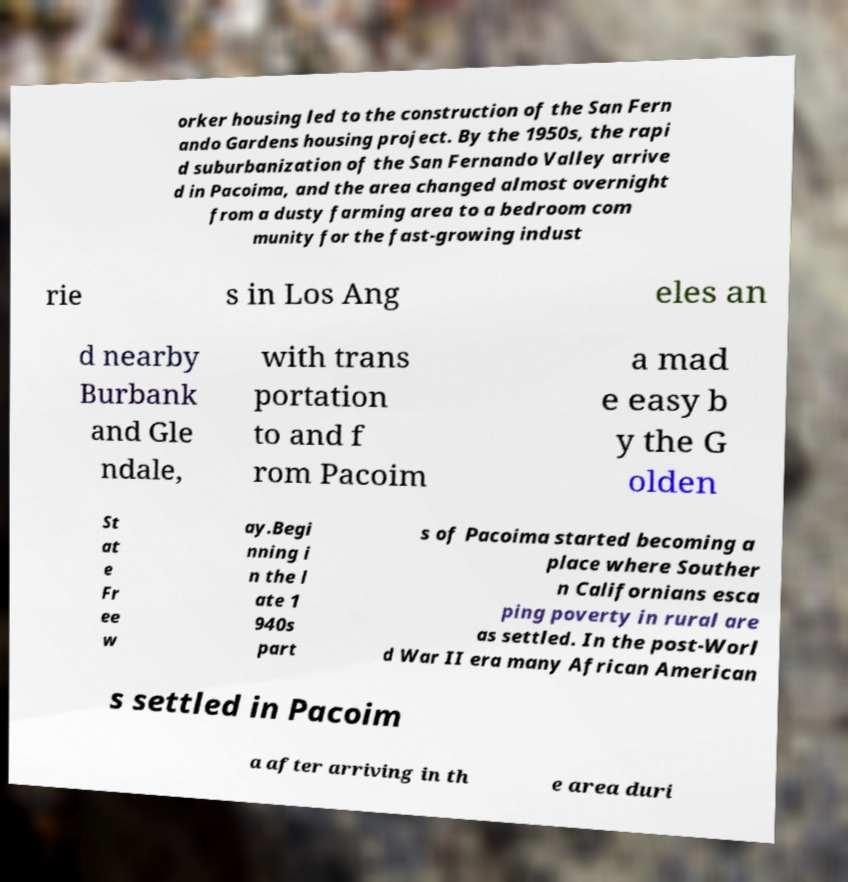Could you extract and type out the text from this image? orker housing led to the construction of the San Fern ando Gardens housing project. By the 1950s, the rapi d suburbanization of the San Fernando Valley arrive d in Pacoima, and the area changed almost overnight from a dusty farming area to a bedroom com munity for the fast-growing indust rie s in Los Ang eles an d nearby Burbank and Gle ndale, with trans portation to and f rom Pacoim a mad e easy b y the G olden St at e Fr ee w ay.Begi nning i n the l ate 1 940s part s of Pacoima started becoming a place where Souther n Californians esca ping poverty in rural are as settled. In the post-Worl d War II era many African American s settled in Pacoim a after arriving in th e area duri 